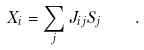<formula> <loc_0><loc_0><loc_500><loc_500>X _ { i } = \sum _ { j } J _ { i j } S _ { j } \quad .</formula> 